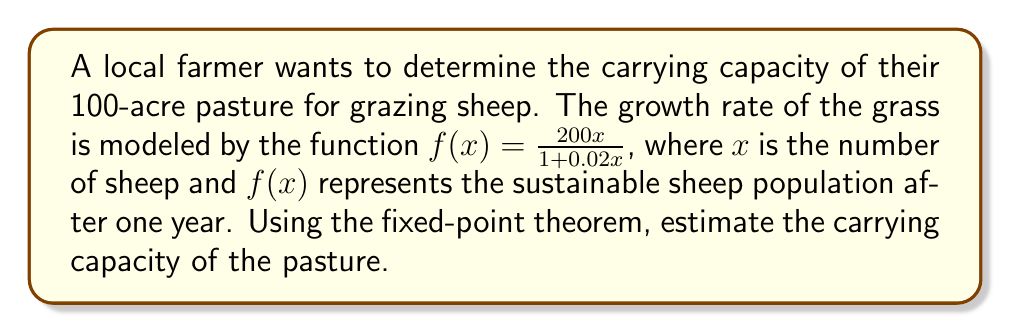Provide a solution to this math problem. To estimate the carrying capacity using the fixed-point theorem, we need to find the fixed point of the given function. A fixed point occurs when $f(x) = x$.

Step 1: Set up the equation
$$\frac{200x}{1 + 0.02x} = x$$

Step 2: Multiply both sides by $(1 + 0.02x)$
$$200x = x(1 + 0.02x)$$
$$200x = x + 0.02x^2$$

Step 3: Rearrange the equation
$$0.02x^2 - 199x = 0$$

Step 4: Factor out $x$
$$x(0.02x - 199) = 0$$

Step 5: Solve for $x$
$x = 0$ or $0.02x - 199 = 0$
$x = 0$ or $x = 9950$

Step 6: Interpret the results
The non-zero solution, $x = 9950$, represents the carrying capacity of the pasture.

Step 7: Adjust for acreage
Since the pasture is 100 acres, we divide the carrying capacity by 100 to get the number of sheep per acre.

Carrying capacity per acre = $9950 / 100 = 99.5$ sheep per acre
Answer: 99.5 sheep per acre 